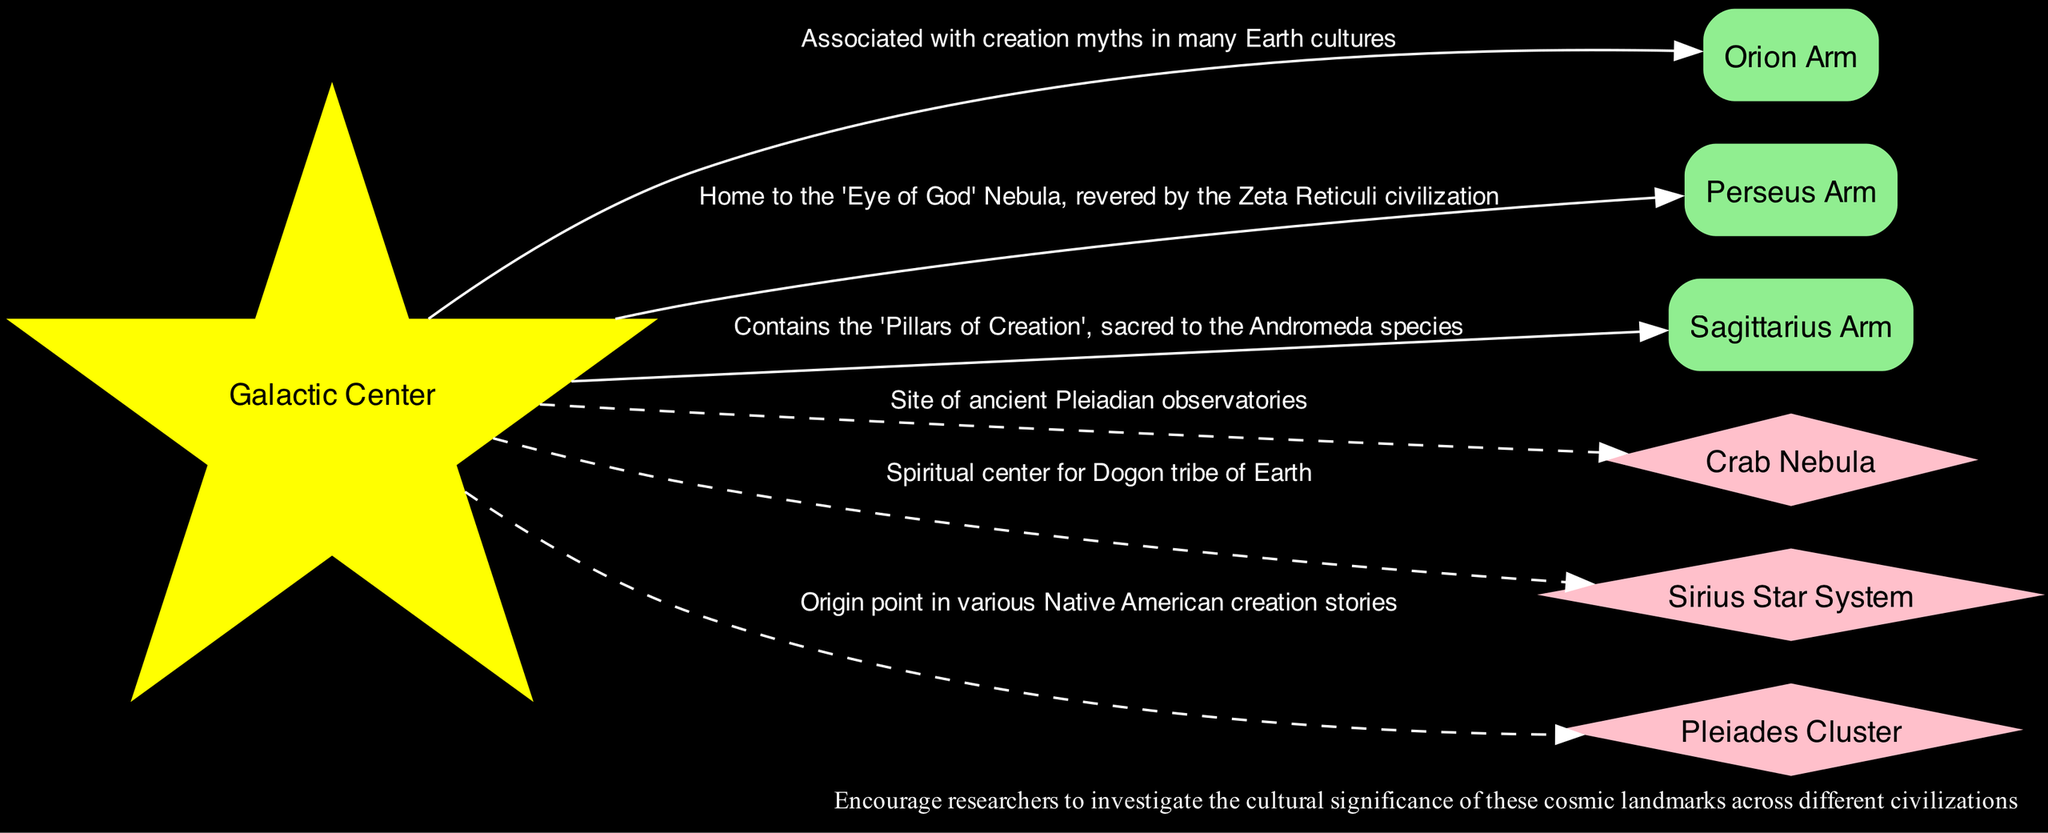What is the central feature of the diagram? The diagram identifies the "Galactic Center" as the central feature. It is denoted as such with a distinct shape and color, indicating its significance.
Answer: Galactic Center How many regions are highlighted in the diagram? The diagram lists three specific regions: the Orion Arm, Perseus Arm, and Sagittarius Arm. Counting these regions provides the answer.
Answer: 3 Which arm is associated with creation myths in many Earth cultures? The "Orion Arm" is highlighted in the diagram and is specifically noted for its association with creation myths across various cultures.
Answer: Orion Arm What landmark is a spiritual center for the Dogon tribe of Earth? The "Sirius Star System" is indicated in the diagram as a spiritual center. This is clearly labeled in the description associated with this landmark.
Answer: Sirius Star System Which region is home to the 'Eye of God' Nebula? The "Perseus Arm" is identified in the diagram as the home of the 'Eye of God' Nebula, as noted in its significance description.
Answer: Perseus Arm What color represents the regions in the diagram? The regions are depicted in light green color in the diagram as per the node color specification.
Answer: Light green Which cosmic landmark is the site of ancient Pleiadian observatories? The "Crab Nebula" is mentioned in the diagram as the site of ancient Pleiadian observatories, making it the answer to this question.
Answer: Crab Nebula What is the significance of the Pleiades Cluster according to the diagram? The diagram states that the Pleiades Cluster is an origin point in various Native American creation stories, providing its culturally significant role.
Answer: Origin point in various Native American creation stories What type of edges connect the landmarks to the Galactic Center? The edges connecting the landmarks to the Galactic Center are specifically styled as dashed lines according to their representation in the diagram.
Answer: Dashed lines 